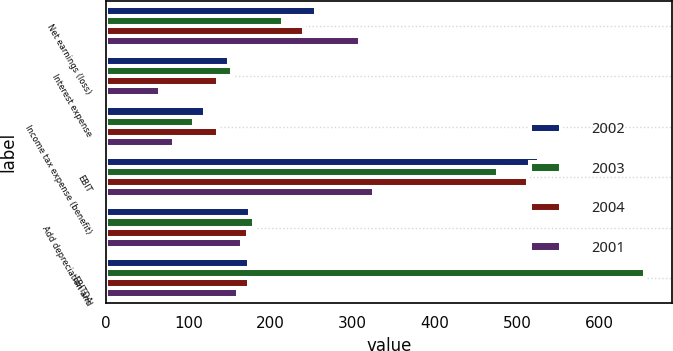Convert chart. <chart><loc_0><loc_0><loc_500><loc_500><stacked_bar_chart><ecel><fcel>Net earnings (loss)<fcel>Interest expense<fcel>Income tax expense (benefit)<fcel>EBIT<fcel>Add depreciation and<fcel>EBITDA<nl><fcel>2002<fcel>255.8<fcel>149.7<fcel>120.8<fcel>526.3<fcel>174.6<fcel>173.9<nl><fcel>2003<fcel>215.6<fcel>153.7<fcel>107.3<fcel>476.6<fcel>179.5<fcel>656.1<nl><fcel>2004<fcel>240.4<fcel>136<fcel>136.5<fcel>512.9<fcel>173.2<fcel>173.9<nl><fcel>2001<fcel>309.1<fcel>65.9<fcel>82.8<fcel>326<fcel>165<fcel>161<nl></chart> 